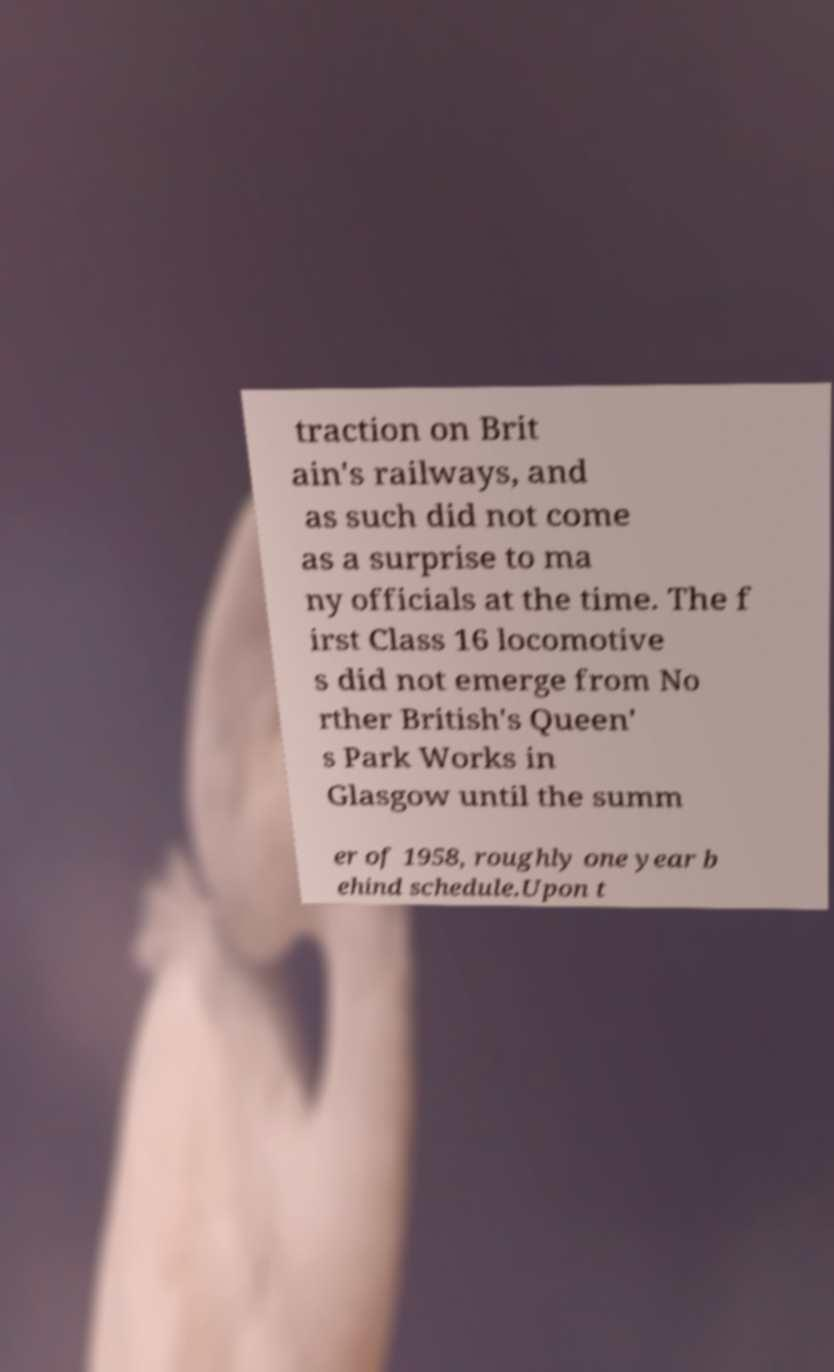Could you extract and type out the text from this image? traction on Brit ain's railways, and as such did not come as a surprise to ma ny officials at the time. The f irst Class 16 locomotive s did not emerge from No rther British's Queen' s Park Works in Glasgow until the summ er of 1958, roughly one year b ehind schedule.Upon t 